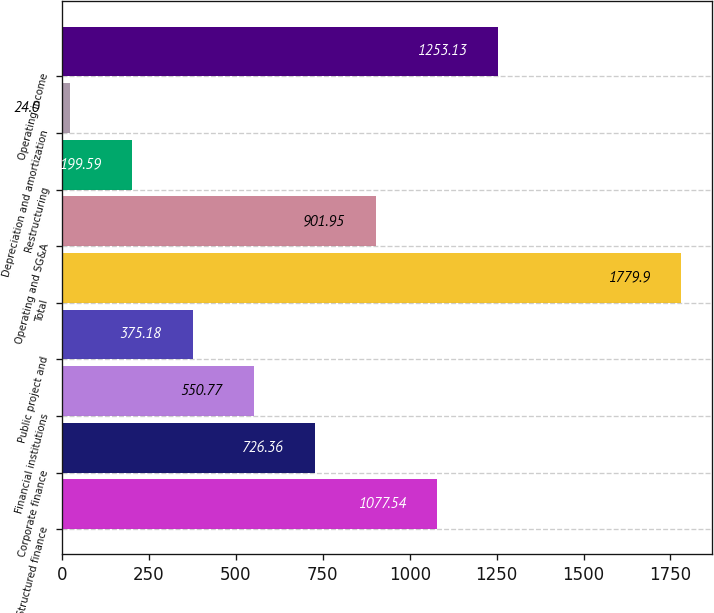Convert chart. <chart><loc_0><loc_0><loc_500><loc_500><bar_chart><fcel>Structured finance<fcel>Corporate finance<fcel>Financial institutions<fcel>Public project and<fcel>Total<fcel>Operating and SG&A<fcel>Restructuring<fcel>Depreciation and amortization<fcel>Operating income<nl><fcel>1077.54<fcel>726.36<fcel>550.77<fcel>375.18<fcel>1779.9<fcel>901.95<fcel>199.59<fcel>24<fcel>1253.13<nl></chart> 